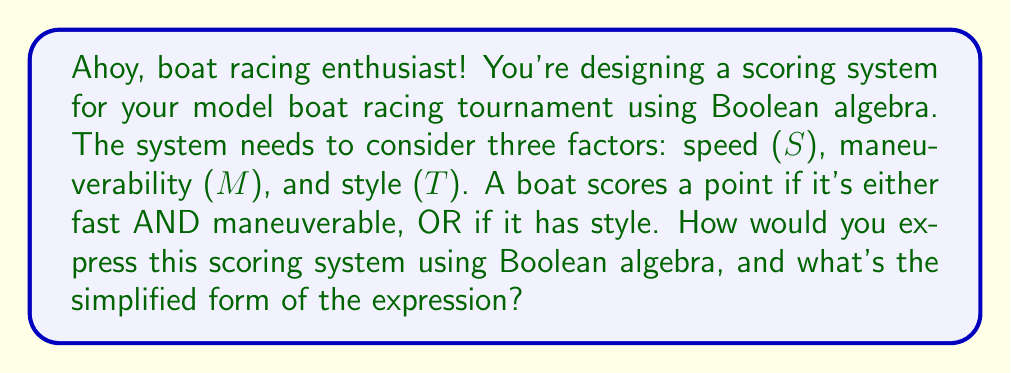Give your solution to this math problem. Let's approach this step-by-step:

1) First, we need to translate the scoring conditions into a Boolean expression:
   - A boat scores if it's fast AND maneuverable: $S \cdot M$
   - OR if it has style: $T$

2) Combining these conditions, we get:
   $$(S \cdot M) + T$$

3) This expression is already quite simple, but we can verify if it can be simplified further using Boolean algebra laws.

4) We can apply the distributive law: $A + (B \cdot C) = (A + B) \cdot (A + C)$
   However, in this case, it would actually make the expression more complex:
   $$(T + S) \cdot (T + M)$$

5) Since applying the distributive law doesn't simplify our expression, we can conclude that $(S \cdot M) + T$ is already in its simplest form.

6) In words, this expression means: A boat scores a point if (it's fast AND maneuverable) OR if it has style.

This Boolean expression efficiently captures the excitement of your model boat racing tournament, considering both technical skills (speed and maneuverability) and the aesthetic appeal (style) of the boats!
Answer: $(S \cdot M) + T$ 